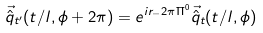Convert formula to latex. <formula><loc_0><loc_0><loc_500><loc_500>\vec { \hat { q } } _ { t ^ { \prime } } ( t / l , \phi + 2 \pi ) = e ^ { i r _ { - } 2 \pi \Pi ^ { 0 } } \vec { \hat { q } } _ { t } ( t / l , \phi )</formula> 